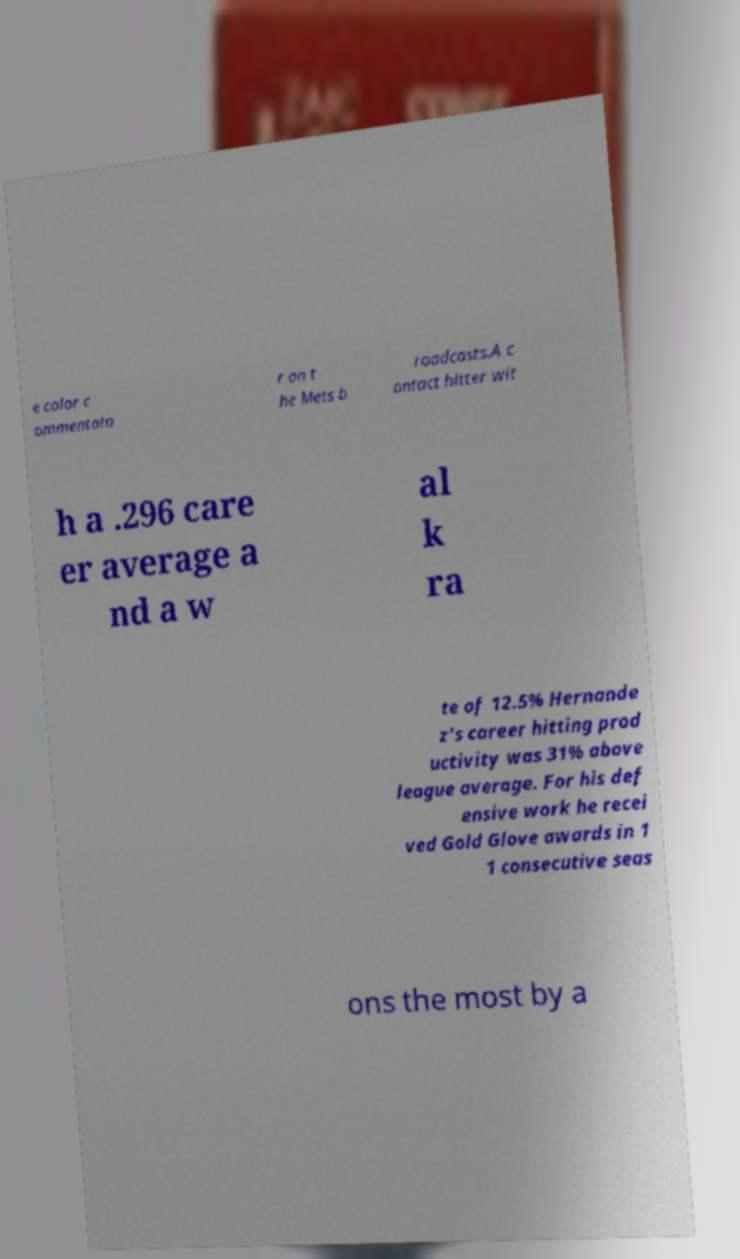Could you assist in decoding the text presented in this image and type it out clearly? e color c ommentato r on t he Mets b roadcasts.A c ontact hitter wit h a .296 care er average a nd a w al k ra te of 12.5% Hernande z's career hitting prod uctivity was 31% above league average. For his def ensive work he recei ved Gold Glove awards in 1 1 consecutive seas ons the most by a 